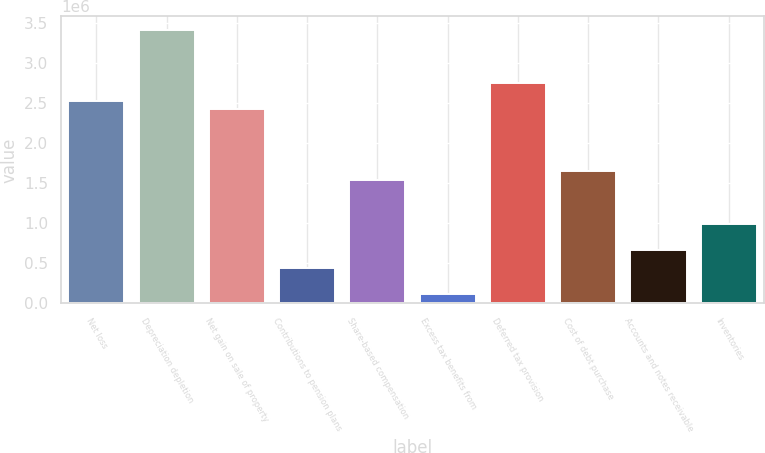Convert chart to OTSL. <chart><loc_0><loc_0><loc_500><loc_500><bar_chart><fcel>Net loss<fcel>Depreciation depletion<fcel>Net gain on sale of property<fcel>Contributions to pension plans<fcel>Share-based compensation<fcel>Excess tax benefits from<fcel>Deferred tax provision<fcel>Cost of debt purchase<fcel>Accounts and notes receivable<fcel>Inventories<nl><fcel>2.52999e+06<fcel>3.40999e+06<fcel>2.41999e+06<fcel>440003<fcel>1.54e+06<fcel>110004<fcel>2.74999e+06<fcel>1.65e+06<fcel>660002<fcel>990000<nl></chart> 